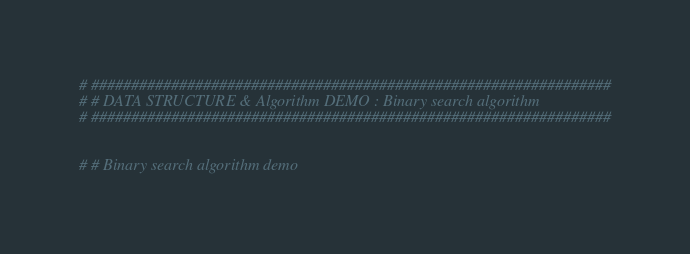<code> <loc_0><loc_0><loc_500><loc_500><_Python_>
# #################################################################
# # DATA STRUCTURE & Algorithm DEMO : Binary search algorithm 
# #################################################################


# # Binary search algorithm demo </code> 